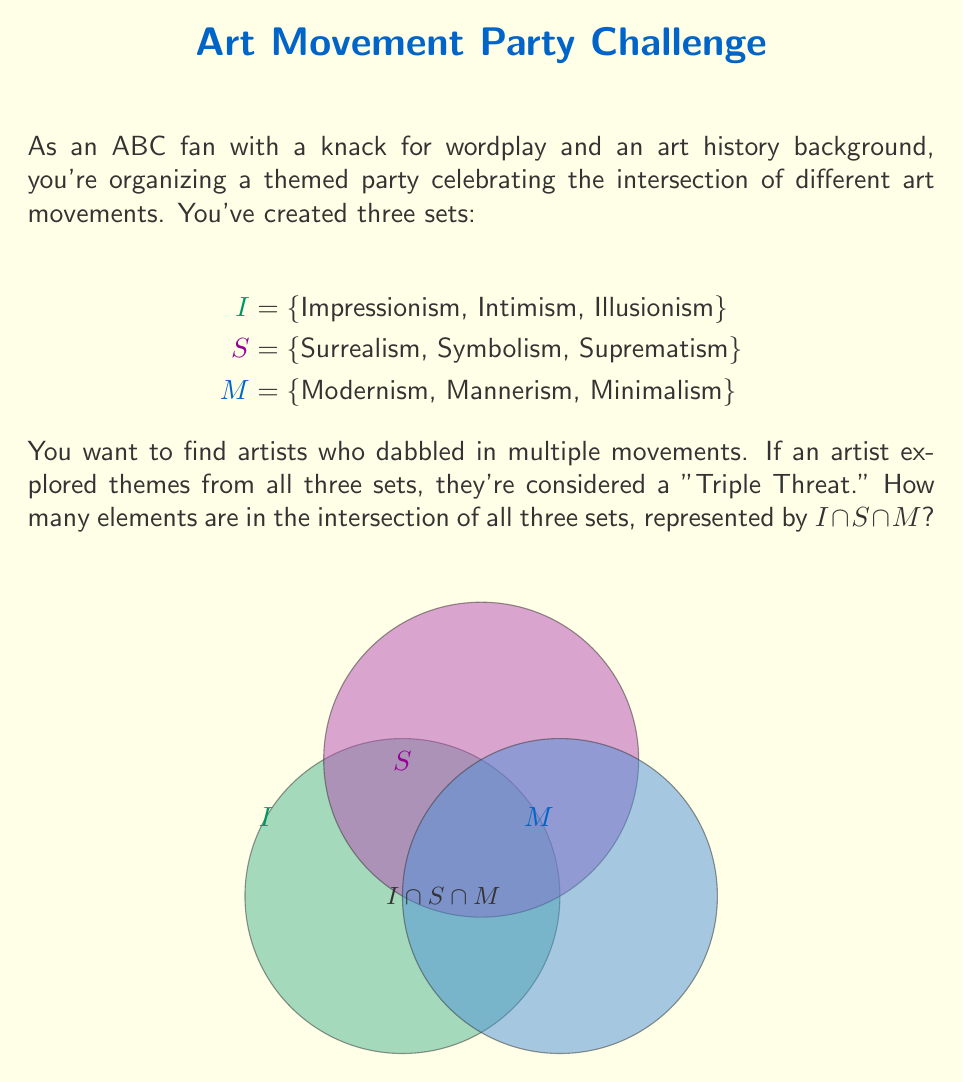Could you help me with this problem? To solve this problem, we need to analyze the given sets and their intersection:

1. First, let's examine each set:
   $$I = \{\text{Impressionism, Intimism, Illusionism}\}$$
   $$S = \{\text{Surrealism, Symbolism, Suprematism}\}$$
   $$M = \{\text{Modernism, Mannerism, Minimalism}\}$$

2. The intersection $I \cap S \cap M$ represents elements that are present in all three sets simultaneously.

3. Looking at the elements of each set, we can see that there are no common elements across all three sets:
   - No element from set $I$ appears in either set $S$ or set $M$.
   - No element from set $S$ appears in either set $I$ or set $M$.
   - No element from set $M$ appears in either set $I$ or set $S$.

4. Therefore, the intersection of all three sets is an empty set:
   $$I \cap S \cap M = \emptyset$$

5. The number of elements in an empty set is always zero.
Answer: $0$ 